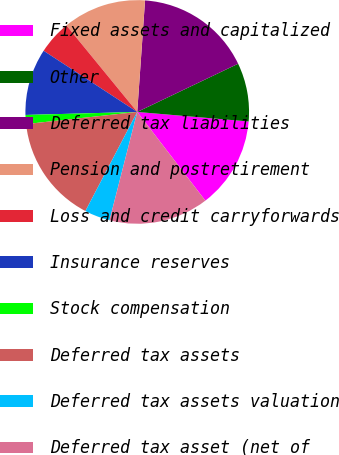<chart> <loc_0><loc_0><loc_500><loc_500><pie_chart><fcel>Fixed assets and capitalized<fcel>Other<fcel>Deferred tax liabilities<fcel>Pension and postretirement<fcel>Loss and credit carryforwards<fcel>Insurance reserves<fcel>Stock compensation<fcel>Deferred tax assets<fcel>Deferred tax assets valuation<fcel>Deferred tax asset (net of<nl><fcel>13.22%<fcel>8.45%<fcel>16.79%<fcel>12.03%<fcel>4.87%<fcel>9.64%<fcel>1.3%<fcel>15.6%<fcel>3.68%<fcel>14.41%<nl></chart> 